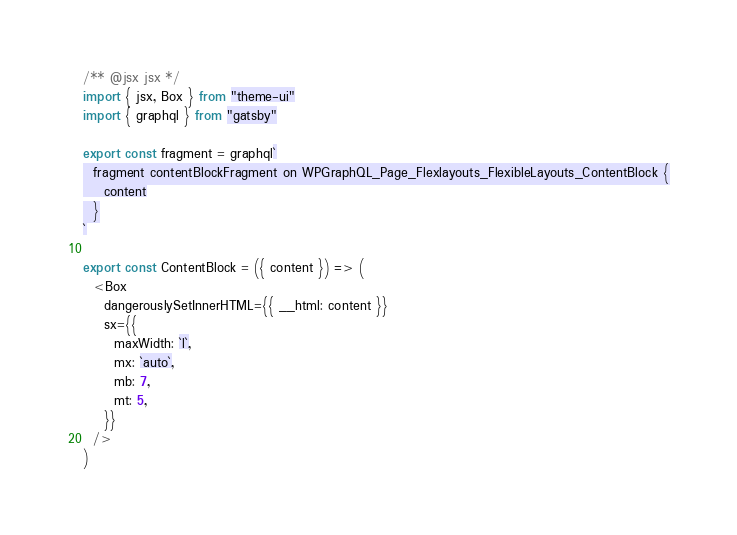Convert code to text. <code><loc_0><loc_0><loc_500><loc_500><_JavaScript_>/** @jsx jsx */
import { jsx, Box } from "theme-ui"
import { graphql } from "gatsby"

export const fragment = graphql`
  fragment contentBlockFragment on WPGraphQL_Page_Flexlayouts_FlexibleLayouts_ContentBlock {
    content
  }
`

export const ContentBlock = ({ content }) => (
  <Box
    dangerouslySetInnerHTML={{ __html: content }}
    sx={{
      maxWidth: `l`,
      mx: `auto`,
      mb: 7,
      mt: 5,
    }}
  />
)
</code> 